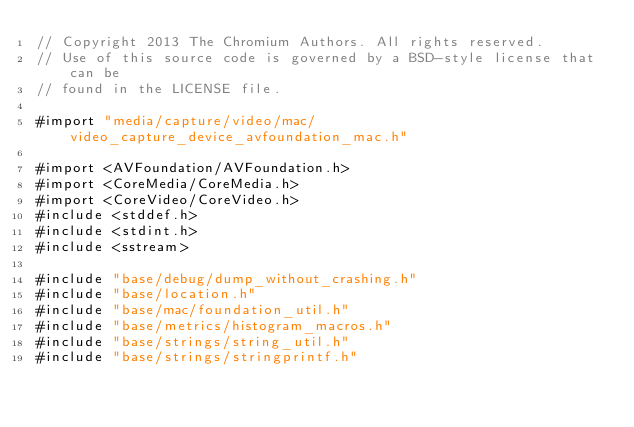<code> <loc_0><loc_0><loc_500><loc_500><_ObjectiveC_>// Copyright 2013 The Chromium Authors. All rights reserved.
// Use of this source code is governed by a BSD-style license that can be
// found in the LICENSE file.

#import "media/capture/video/mac/video_capture_device_avfoundation_mac.h"

#import <AVFoundation/AVFoundation.h>
#import <CoreMedia/CoreMedia.h>
#import <CoreVideo/CoreVideo.h>
#include <stddef.h>
#include <stdint.h>
#include <sstream>

#include "base/debug/dump_without_crashing.h"
#include "base/location.h"
#include "base/mac/foundation_util.h"
#include "base/metrics/histogram_macros.h"
#include "base/strings/string_util.h"
#include "base/strings/stringprintf.h"</code> 